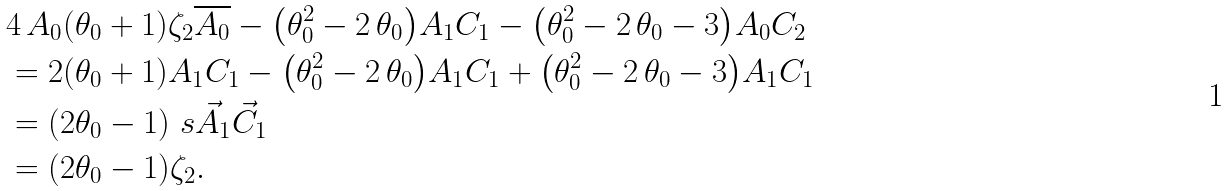<formula> <loc_0><loc_0><loc_500><loc_500>& 4 \, A _ { 0 } { \left ( \theta _ { 0 } + 1 \right ) } \zeta _ { 2 } \overline { A _ { 0 } } - { \left ( \theta _ { 0 } ^ { 2 } - 2 \, \theta _ { 0 } \right ) } A _ { 1 } C _ { 1 } - { \left ( \theta _ { 0 } ^ { 2 } - 2 \, \theta _ { 0 } - 3 \right ) } A _ { 0 } C _ { 2 } \\ & = 2 ( \theta _ { 0 } + 1 ) A _ { 1 } C _ { 1 } - { \left ( \theta _ { 0 } ^ { 2 } - 2 \, \theta _ { 0 } \right ) } A _ { 1 } C _ { 1 } + { \left ( \theta _ { 0 } ^ { 2 } - 2 \, \theta _ { 0 } - 3 \right ) } A _ { 1 } C _ { 1 } \\ & = ( 2 \theta _ { 0 } - 1 ) \ s { \vec { A } _ { 1 } } { \vec { C } _ { 1 } } \\ & = ( 2 \theta _ { 0 } - 1 ) \zeta _ { 2 } .</formula> 